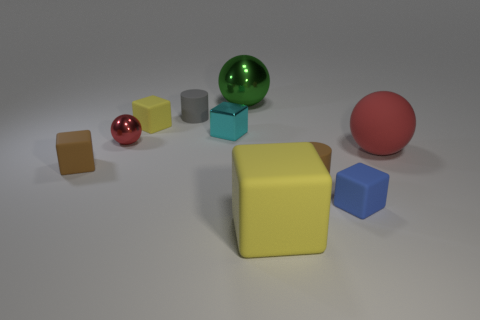Subtract all brown blocks. How many blocks are left? 4 Subtract all metal blocks. How many blocks are left? 4 Subtract 2 blocks. How many blocks are left? 3 Subtract all cyan cubes. Subtract all purple spheres. How many cubes are left? 4 Subtract all balls. How many objects are left? 7 Add 6 tiny yellow cubes. How many tiny yellow cubes are left? 7 Add 5 brown shiny balls. How many brown shiny balls exist? 5 Subtract 0 purple cylinders. How many objects are left? 10 Subtract all red metal things. Subtract all small green matte things. How many objects are left? 9 